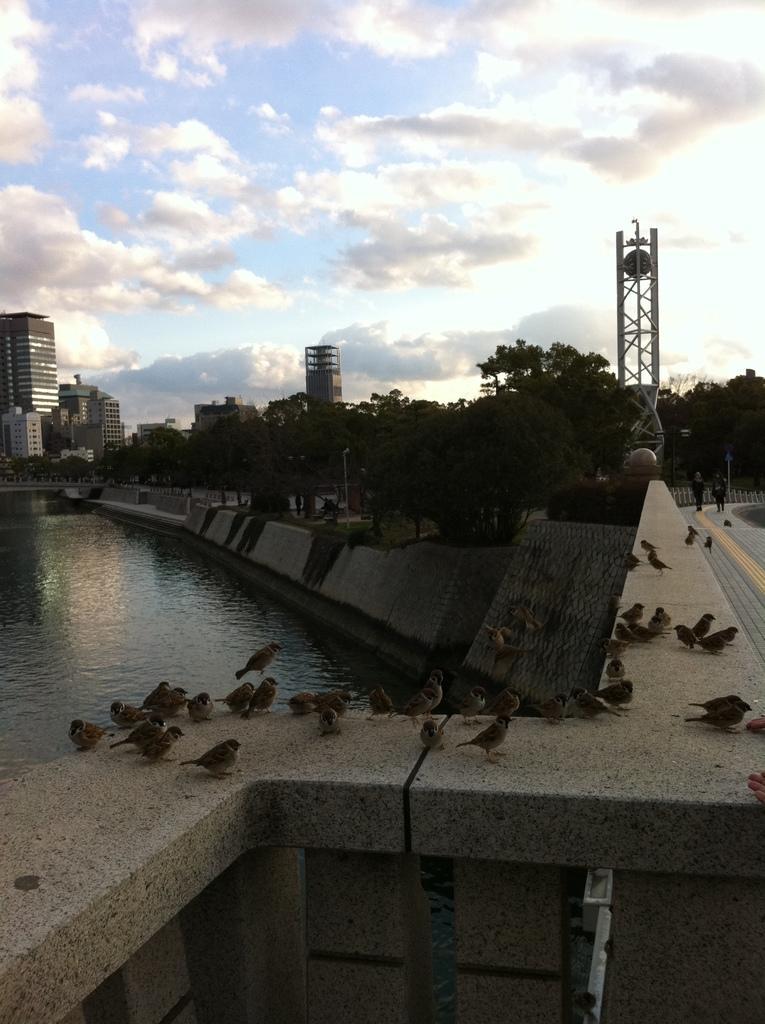In one or two sentences, can you explain what this image depicts? In this image at the bottom there is a wall on the wall there are some birds, and on the left side there is a small river. And in the background we could see some buildings, towers and trees. On the right side there is a road and two persons are walking, on the top of the image there is sky. 